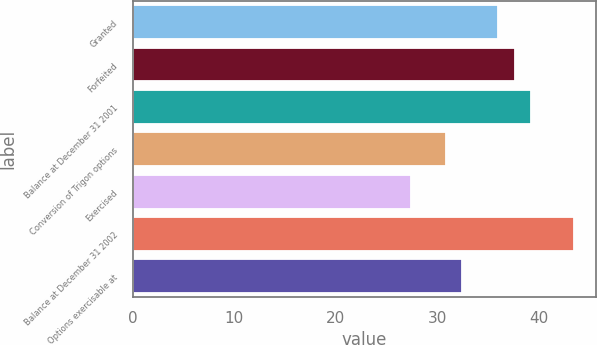Convert chart to OTSL. <chart><loc_0><loc_0><loc_500><loc_500><bar_chart><fcel>Granted<fcel>Forfeited<fcel>Balance at December 31 2001<fcel>Conversion of Trigon options<fcel>Exercised<fcel>Balance at December 31 2002<fcel>Options exercisable at<nl><fcel>36<fcel>37.61<fcel>39.22<fcel>30.86<fcel>27.36<fcel>43.48<fcel>32.47<nl></chart> 